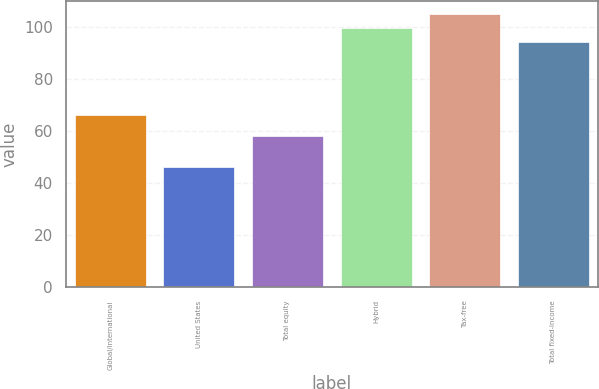Convert chart to OTSL. <chart><loc_0><loc_0><loc_500><loc_500><bar_chart><fcel>Global/international<fcel>United States<fcel>Total equity<fcel>Hybrid<fcel>Tax-free<fcel>Total fixed-income<nl><fcel>66<fcel>46<fcel>58<fcel>99.4<fcel>104.8<fcel>94<nl></chart> 